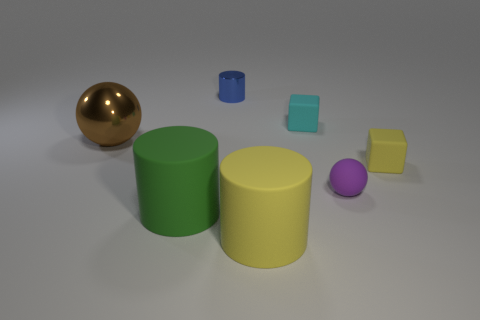What is the material of the cube that is the same size as the cyan object?
Keep it short and to the point. Rubber. What material is the tiny object that is right of the rubber sphere that is in front of the tiny cube in front of the metallic ball?
Offer a terse response. Rubber. What color is the large metal thing?
Your answer should be very brief. Brown. How many big things are green rubber things or brown cylinders?
Give a very brief answer. 1. Is the material of the small object on the left side of the yellow matte cylinder the same as the large yellow thing that is in front of the large green thing?
Your response must be concise. No. Is there a small cyan block?
Give a very brief answer. Yes. Is the number of small yellow cubes that are behind the blue metal thing greater than the number of yellow cylinders left of the brown object?
Your response must be concise. No. There is a tiny purple object that is the same shape as the brown thing; what material is it?
Your answer should be very brief. Rubber. Is there anything else that is the same size as the cyan matte block?
Keep it short and to the point. Yes. Is the color of the large matte thing right of the small metal object the same as the cube that is behind the tiny yellow rubber cube?
Give a very brief answer. No. 